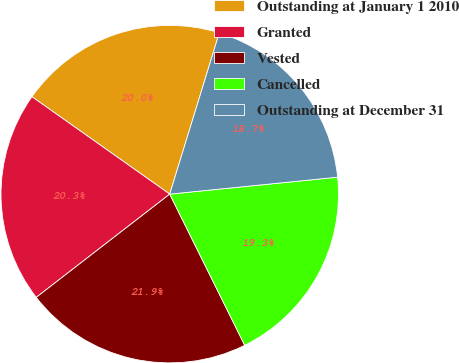Convert chart. <chart><loc_0><loc_0><loc_500><loc_500><pie_chart><fcel>Outstanding at January 1 2010<fcel>Granted<fcel>Vested<fcel>Cancelled<fcel>Outstanding at December 31<nl><fcel>19.95%<fcel>20.27%<fcel>21.85%<fcel>19.27%<fcel>18.65%<nl></chart> 